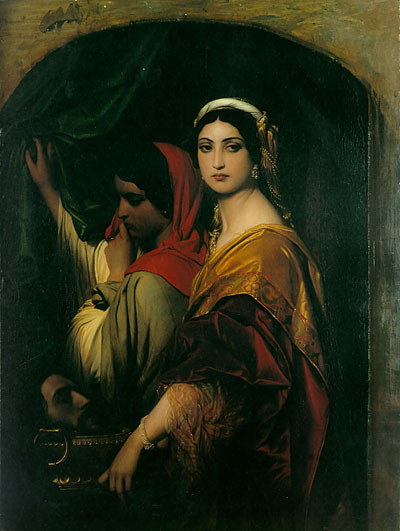Can you describe the significance of the colors used in this painting? The colors in this painting are deeply symbolic and carefully chosen to enhance the narrative and emotional depth of the scene. The dominant reds are often associated with passion, power, and importance, which might be reflective of the standing or the emotional state of the characters. Gold suggests not only wealth but also an otherworldly or sacred quality, perhaps elevating the figure's status beyond the mundane. The use of a green curtain, separating the figures from what lies beyond, could symbolize a transition or barrier, hinting at themes of hidden truths or moments just out of reach. These colors, in their rich saturation, contribute to the painting's dramatic and intense ambiance, guiding the viewer's emotional response and further narrativizing the artwork. 